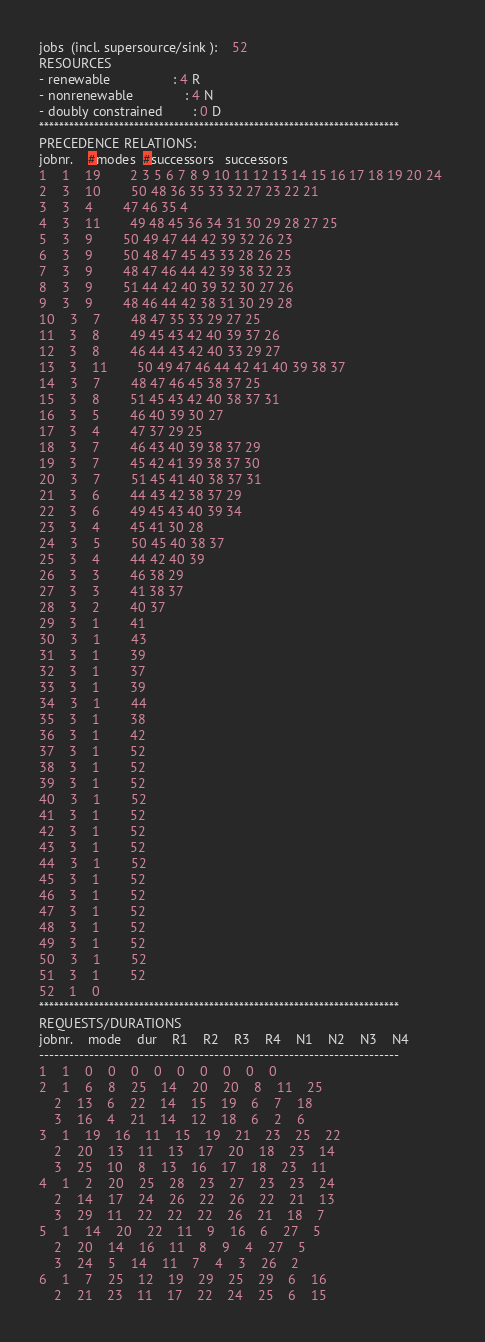Convert code to text. <code><loc_0><loc_0><loc_500><loc_500><_ObjectiveC_>jobs  (incl. supersource/sink ):	52
RESOURCES
- renewable                 : 4 R
- nonrenewable              : 4 N
- doubly constrained        : 0 D
************************************************************************
PRECEDENCE RELATIONS:
jobnr.    #modes  #successors   successors
1	1	19		2 3 5 6 7 8 9 10 11 12 13 14 15 16 17 18 19 20 24 
2	3	10		50 48 36 35 33 32 27 23 22 21 
3	3	4		47 46 35 4 
4	3	11		49 48 45 36 34 31 30 29 28 27 25 
5	3	9		50 49 47 44 42 39 32 26 23 
6	3	9		50 48 47 45 43 33 28 26 25 
7	3	9		48 47 46 44 42 39 38 32 23 
8	3	9		51 44 42 40 39 32 30 27 26 
9	3	9		48 46 44 42 38 31 30 29 28 
10	3	7		48 47 35 33 29 27 25 
11	3	8		49 45 43 42 40 39 37 26 
12	3	8		46 44 43 42 40 33 29 27 
13	3	11		50 49 47 46 44 42 41 40 39 38 37 
14	3	7		48 47 46 45 38 37 25 
15	3	8		51 45 43 42 40 38 37 31 
16	3	5		46 40 39 30 27 
17	3	4		47 37 29 25 
18	3	7		46 43 40 39 38 37 29 
19	3	7		45 42 41 39 38 37 30 
20	3	7		51 45 41 40 38 37 31 
21	3	6		44 43 42 38 37 29 
22	3	6		49 45 43 40 39 34 
23	3	4		45 41 30 28 
24	3	5		50 45 40 38 37 
25	3	4		44 42 40 39 
26	3	3		46 38 29 
27	3	3		41 38 37 
28	3	2		40 37 
29	3	1		41 
30	3	1		43 
31	3	1		39 
32	3	1		37 
33	3	1		39 
34	3	1		44 
35	3	1		38 
36	3	1		42 
37	3	1		52 
38	3	1		52 
39	3	1		52 
40	3	1		52 
41	3	1		52 
42	3	1		52 
43	3	1		52 
44	3	1		52 
45	3	1		52 
46	3	1		52 
47	3	1		52 
48	3	1		52 
49	3	1		52 
50	3	1		52 
51	3	1		52 
52	1	0		
************************************************************************
REQUESTS/DURATIONS
jobnr.	mode	dur	R1	R2	R3	R4	N1	N2	N3	N4	
------------------------------------------------------------------------
1	1	0	0	0	0	0	0	0	0	0	
2	1	6	8	25	14	20	20	8	11	25	
	2	13	6	22	14	15	19	6	7	18	
	3	16	4	21	14	12	18	6	2	6	
3	1	19	16	11	15	19	21	23	25	22	
	2	20	13	11	13	17	20	18	23	14	
	3	25	10	8	13	16	17	18	23	11	
4	1	2	20	25	28	23	27	23	23	24	
	2	14	17	24	26	22	26	22	21	13	
	3	29	11	22	22	22	26	21	18	7	
5	1	14	20	22	11	9	16	6	27	5	
	2	20	14	16	11	8	9	4	27	5	
	3	24	5	14	11	7	4	3	26	2	
6	1	7	25	12	19	29	25	29	6	16	
	2	21	23	11	17	22	24	25	6	15	</code> 